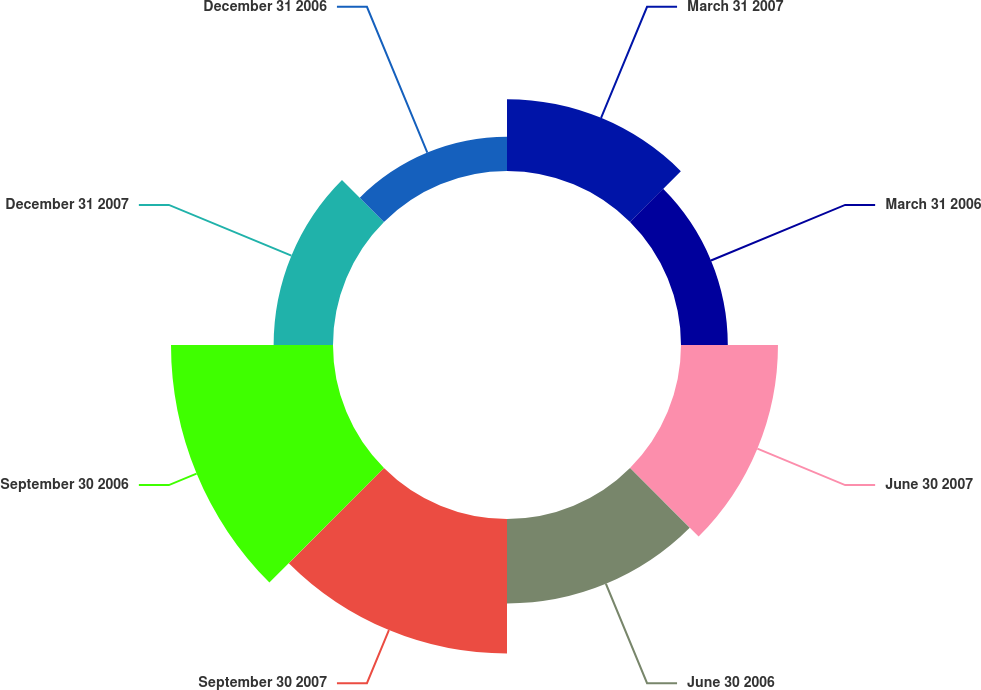<chart> <loc_0><loc_0><loc_500><loc_500><pie_chart><fcel>March 31 2007<fcel>March 31 2006<fcel>June 30 2007<fcel>June 30 2006<fcel>September 30 2007<fcel>September 30 2006<fcel>December 31 2007<fcel>December 31 2006<nl><fcel>10.41%<fcel>6.78%<fcel>14.05%<fcel>12.23%<fcel>19.5%<fcel>23.47%<fcel>8.6%<fcel>4.96%<nl></chart> 